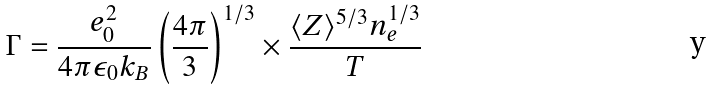<formula> <loc_0><loc_0><loc_500><loc_500>\Gamma = \frac { e _ { 0 } ^ { 2 } } { 4 \pi \epsilon _ { 0 } k _ { B } } \left ( \frac { 4 \pi } { 3 } \right ) ^ { 1 / 3 } \times \frac { \langle Z \rangle ^ { 5 / 3 } n _ { e } ^ { 1 / 3 } } { T }</formula> 